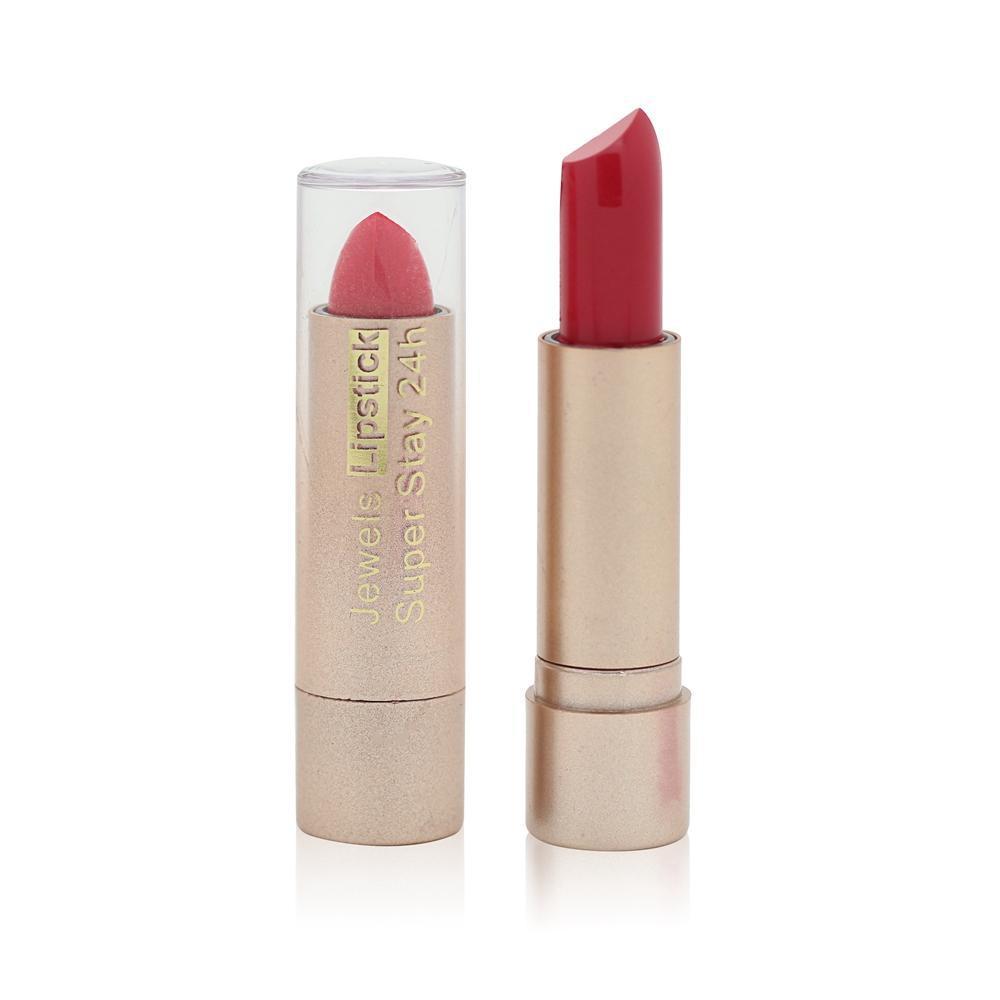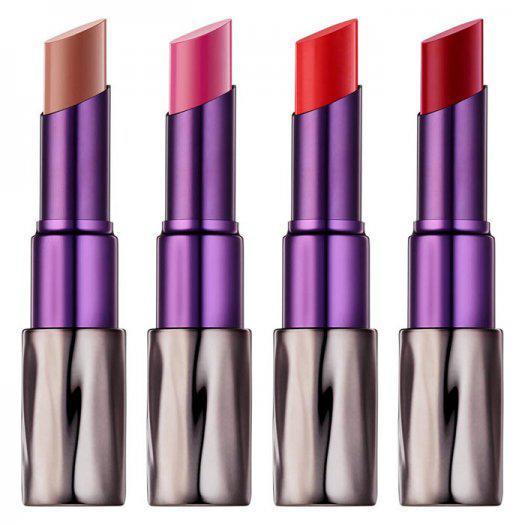The first image is the image on the left, the second image is the image on the right. Given the left and right images, does the statement "The left image shows one lipstick next to its cap." hold true? Answer yes or no. No. The first image is the image on the left, the second image is the image on the right. Considering the images on both sides, is "The left image shows exactly one lipstick next to its cap." valid? Answer yes or no. No. 